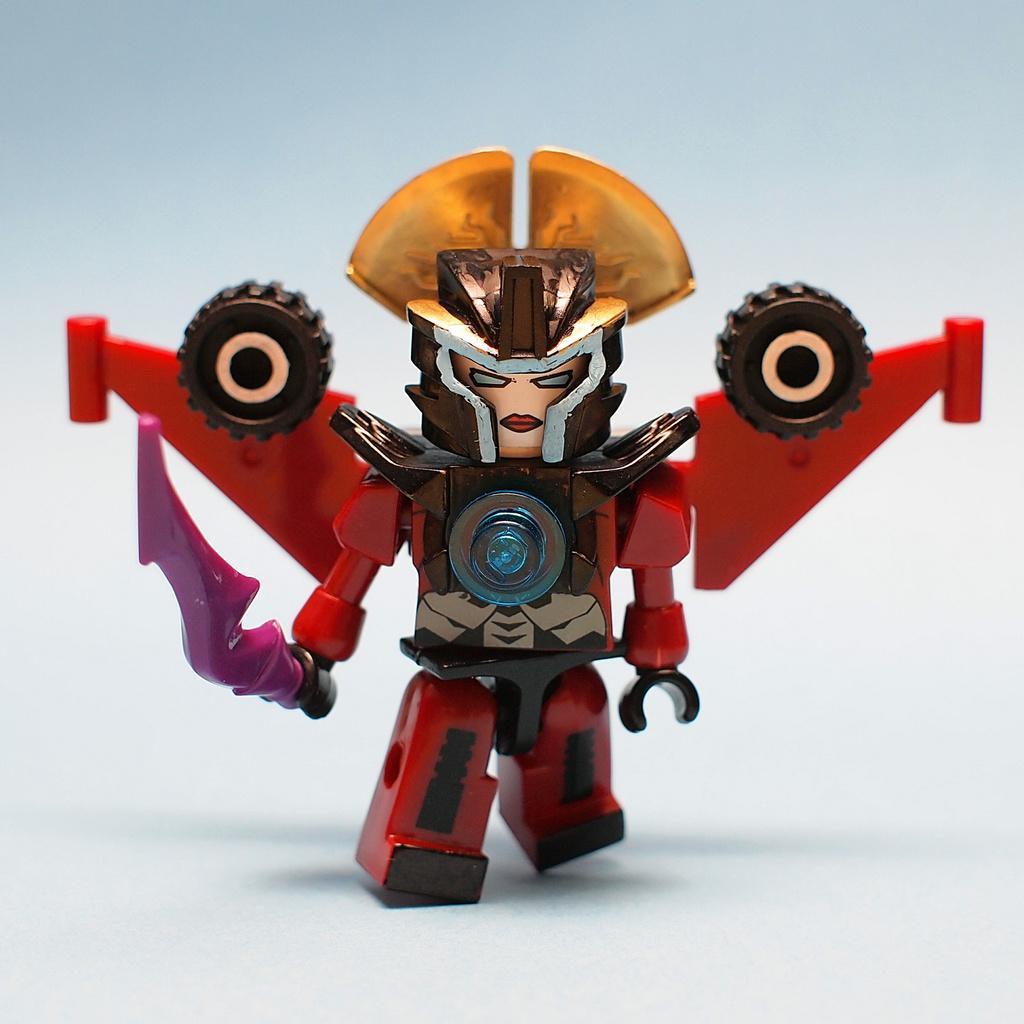In one or two sentences, can you explain what this image depicts? In the foreground of this image, there is a toy on a white surface. 